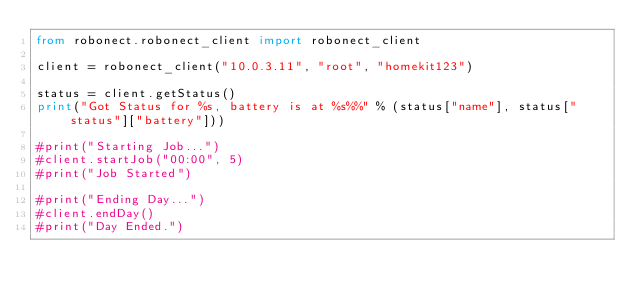Convert code to text. <code><loc_0><loc_0><loc_500><loc_500><_Python_>from robonect.robonect_client import robonect_client

client = robonect_client("10.0.3.11", "root", "homekit123")

status = client.getStatus()
print("Got Status for %s, battery is at %s%%" % (status["name"], status["status"]["battery"]))

#print("Starting Job...")
#client.startJob("00:00", 5)
#print("Job Started")

#print("Ending Day...")
#client.endDay()
#print("Day Ended.")
</code> 